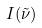<formula> <loc_0><loc_0><loc_500><loc_500>I ( \tilde { \nu } )</formula> 